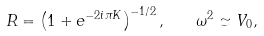Convert formula to latex. <formula><loc_0><loc_0><loc_500><loc_500>R = \left ( 1 + e ^ { - 2 i \pi K } \right ) ^ { - 1 / 2 } , \quad \omega ^ { 2 } \simeq V _ { 0 } ,</formula> 